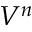<formula> <loc_0><loc_0><loc_500><loc_500>V ^ { n }</formula> 